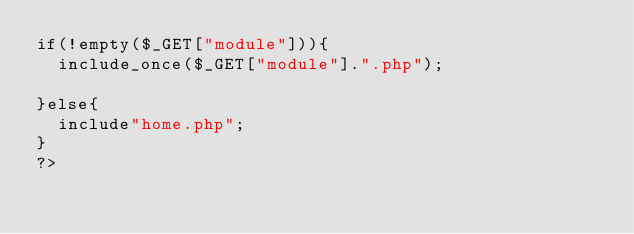<code> <loc_0><loc_0><loc_500><loc_500><_PHP_>if(!empty($_GET["module"])){
	include_once($_GET["module"].".php");
	
}else{
	include"home.php";
}
?></code> 